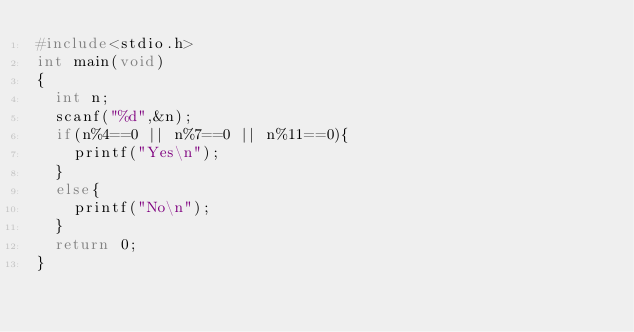Convert code to text. <code><loc_0><loc_0><loc_500><loc_500><_C_>#include<stdio.h>
int main(void)
{
	int n;
	scanf("%d",&n);
	if(n%4==0 || n%7==0 || n%11==0){
		printf("Yes\n");
	}
	else{
		printf("No\n");
	}
	return 0;
}</code> 